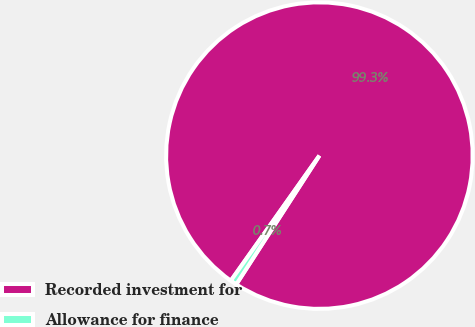Convert chart to OTSL. <chart><loc_0><loc_0><loc_500><loc_500><pie_chart><fcel>Recorded investment for<fcel>Allowance for finance<nl><fcel>99.32%<fcel>0.68%<nl></chart> 